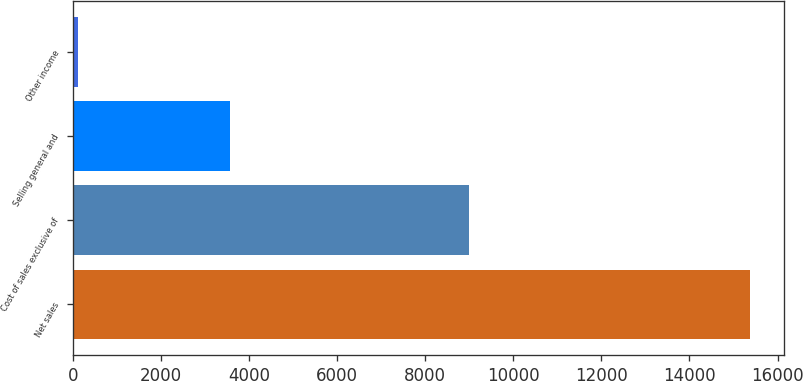Convert chart. <chart><loc_0><loc_0><loc_500><loc_500><bar_chart><fcel>Net sales<fcel>Cost of sales exclusive of<fcel>Selling general and<fcel>Other income<nl><fcel>15374<fcel>9001<fcel>3573<fcel>114<nl></chart> 